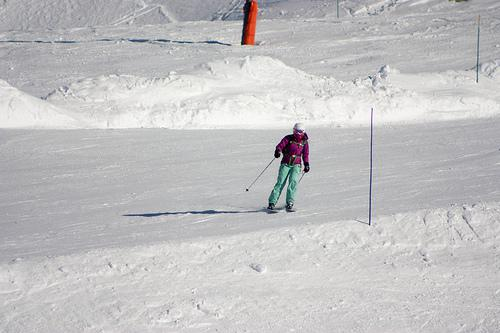Question: how many people are pictured here?
Choices:
A. 12.
B. 13.
C. 1.
D. 5.
Answer with the letter. Answer: C Question: what time of year was this photo likely taken?
Choices:
A. Winter.
B. Summer.
C. Spring.
D. Fall.
Answer with the letter. Answer: A Question: where was this picture taken?
Choices:
A. A beach.
B. A ski slope.
C. On a golf course.
D. In a school.
Answer with the letter. Answer: B Question: what color is the post in the background?
Choices:
A. Teal.
B. Purple.
C. Orange.
D. Neon.
Answer with the letter. Answer: C Question: what color is the person's jacket?
Choices:
A. Teal.
B. Tangerine.
C. Neon.
D. Purple.
Answer with the letter. Answer: D Question: how many animals appear in this picture?
Choices:
A. 12.
B. 0.
C. 13.
D. 5.
Answer with the letter. Answer: B 